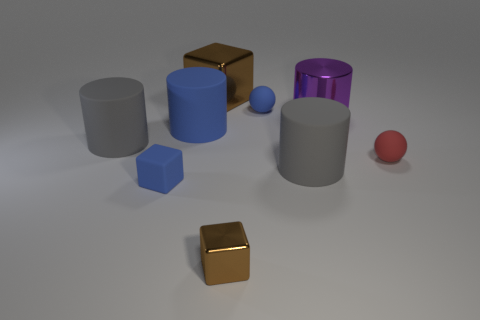How many other small matte things have the same shape as the tiny red object?
Offer a very short reply. 1. There is a blue sphere that is the same size as the rubber block; what material is it?
Provide a succinct answer. Rubber. Is there a small blue thing made of the same material as the blue sphere?
Give a very brief answer. Yes. Are there fewer large shiny objects that are behind the large brown thing than big cyan shiny spheres?
Your answer should be very brief. No. The big object behind the small sphere that is behind the blue cylinder is made of what material?
Keep it short and to the point. Metal. There is a large thing that is in front of the large blue rubber object and behind the tiny red matte thing; what shape is it?
Provide a short and direct response. Cylinder. How many other objects are the same color as the big shiny cylinder?
Offer a very short reply. 0. What number of things are gray cylinders that are on the left side of the tiny blue matte cube or matte objects?
Ensure brevity in your answer.  6. Do the tiny rubber block and the small ball behind the tiny red matte ball have the same color?
Your answer should be very brief. Yes. How big is the gray cylinder that is to the left of the blue rubber thing that is on the right side of the big brown object?
Provide a short and direct response. Large. 